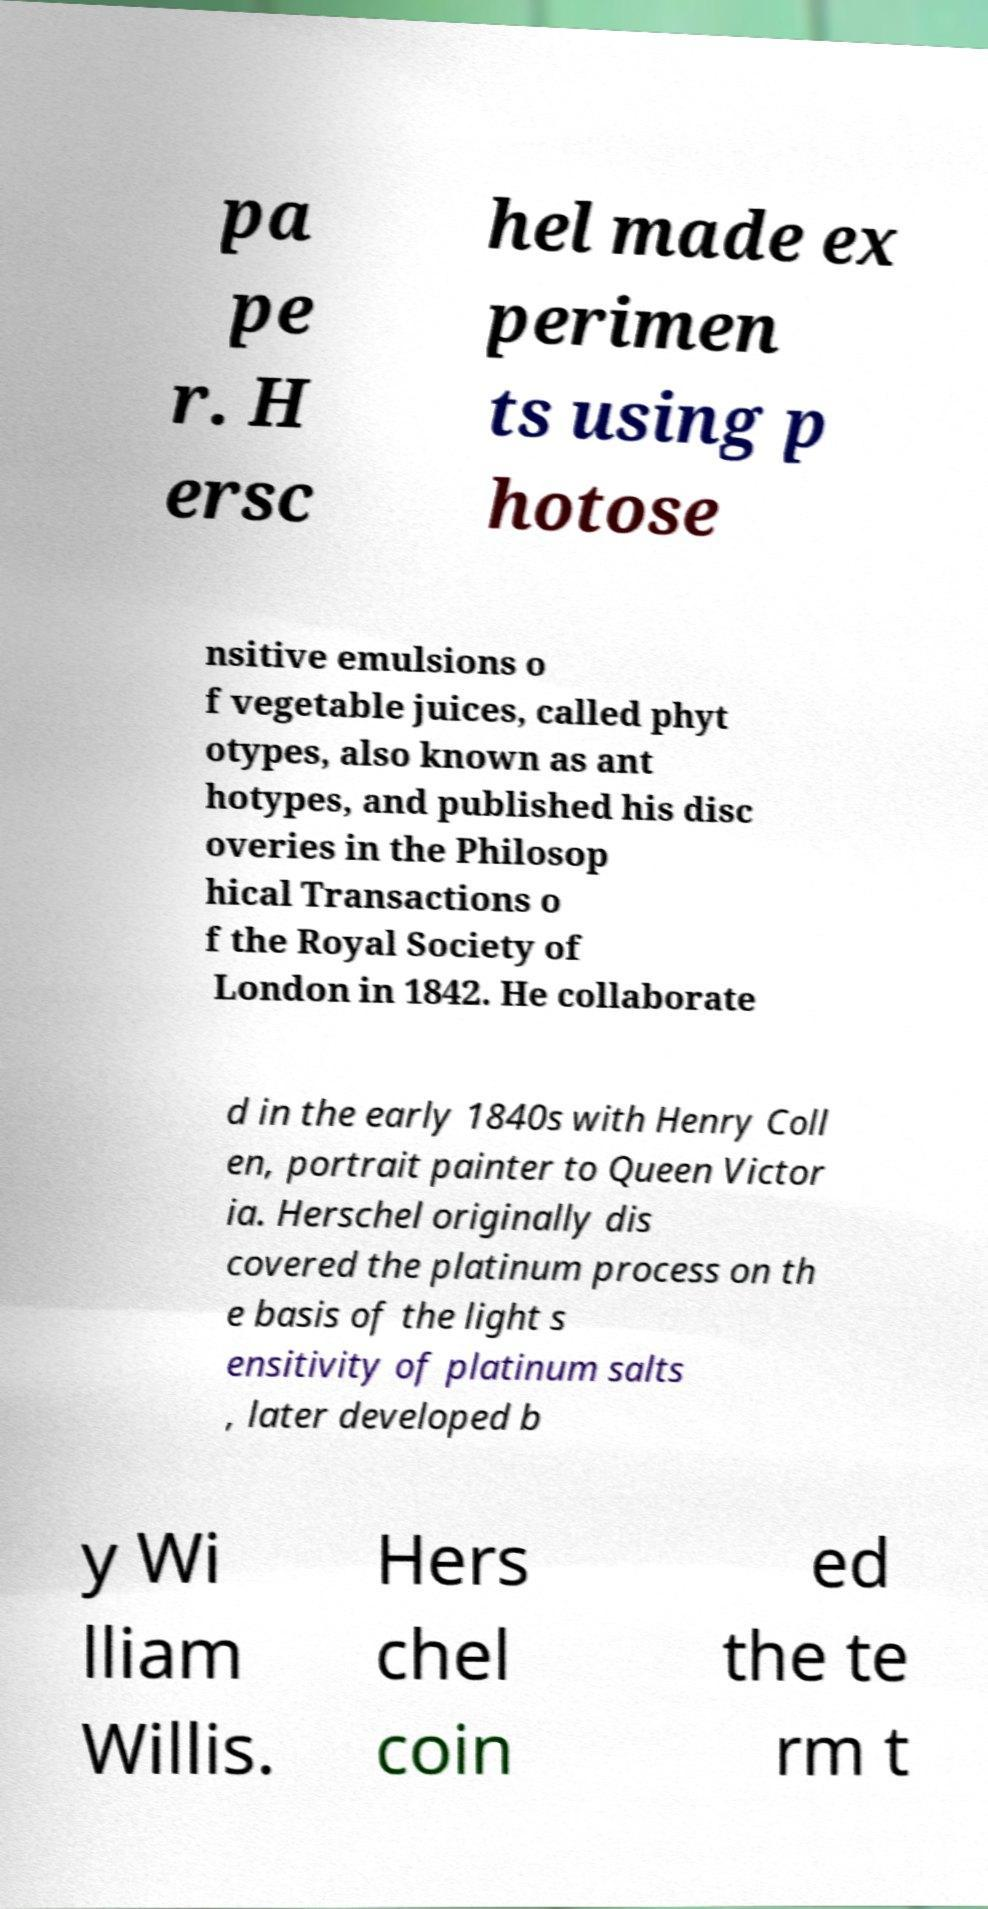Please read and relay the text visible in this image. What does it say? pa pe r. H ersc hel made ex perimen ts using p hotose nsitive emulsions o f vegetable juices, called phyt otypes, also known as ant hotypes, and published his disc overies in the Philosop hical Transactions o f the Royal Society of London in 1842. He collaborate d in the early 1840s with Henry Coll en, portrait painter to Queen Victor ia. Herschel originally dis covered the platinum process on th e basis of the light s ensitivity of platinum salts , later developed b y Wi lliam Willis. Hers chel coin ed the te rm t 